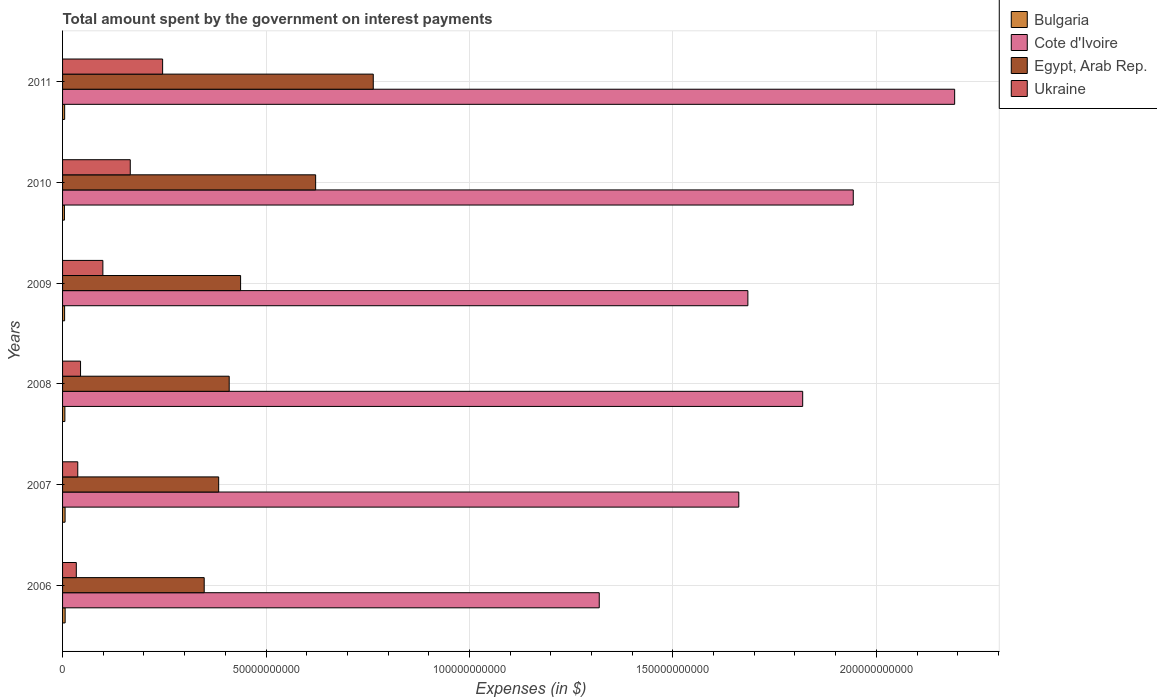How many groups of bars are there?
Provide a succinct answer. 6. Are the number of bars on each tick of the Y-axis equal?
Make the answer very short. Yes. How many bars are there on the 6th tick from the bottom?
Offer a terse response. 4. What is the label of the 6th group of bars from the top?
Your answer should be very brief. 2006. What is the amount spent on interest payments by the government in Cote d'Ivoire in 2010?
Provide a succinct answer. 1.94e+11. Across all years, what is the maximum amount spent on interest payments by the government in Ukraine?
Offer a very short reply. 2.46e+1. Across all years, what is the minimum amount spent on interest payments by the government in Bulgaria?
Provide a short and direct response. 4.60e+08. In which year was the amount spent on interest payments by the government in Bulgaria maximum?
Your answer should be compact. 2006. What is the total amount spent on interest payments by the government in Egypt, Arab Rep. in the graph?
Your answer should be very brief. 2.96e+11. What is the difference between the amount spent on interest payments by the government in Ukraine in 2009 and that in 2011?
Keep it short and to the point. -1.47e+1. What is the difference between the amount spent on interest payments by the government in Egypt, Arab Rep. in 2009 and the amount spent on interest payments by the government in Ukraine in 2008?
Your answer should be compact. 3.93e+1. What is the average amount spent on interest payments by the government in Egypt, Arab Rep. per year?
Your answer should be compact. 4.94e+1. In the year 2010, what is the difference between the amount spent on interest payments by the government in Bulgaria and amount spent on interest payments by the government in Ukraine?
Offer a terse response. -1.62e+1. What is the ratio of the amount spent on interest payments by the government in Bulgaria in 2006 to that in 2008?
Your answer should be very brief. 1.11. Is the difference between the amount spent on interest payments by the government in Bulgaria in 2007 and 2011 greater than the difference between the amount spent on interest payments by the government in Ukraine in 2007 and 2011?
Make the answer very short. Yes. What is the difference between the highest and the second highest amount spent on interest payments by the government in Egypt, Arab Rep.?
Your answer should be compact. 1.42e+1. What is the difference between the highest and the lowest amount spent on interest payments by the government in Cote d'Ivoire?
Your answer should be compact. 8.74e+1. Is it the case that in every year, the sum of the amount spent on interest payments by the government in Bulgaria and amount spent on interest payments by the government in Cote d'Ivoire is greater than the sum of amount spent on interest payments by the government in Egypt, Arab Rep. and amount spent on interest payments by the government in Ukraine?
Make the answer very short. Yes. What is the difference between two consecutive major ticks on the X-axis?
Your answer should be compact. 5.00e+1. Does the graph contain any zero values?
Offer a very short reply. No. Does the graph contain grids?
Your answer should be very brief. Yes. Where does the legend appear in the graph?
Provide a short and direct response. Top right. What is the title of the graph?
Give a very brief answer. Total amount spent by the government on interest payments. What is the label or title of the X-axis?
Your response must be concise. Expenses (in $). What is the Expenses (in $) in Bulgaria in 2006?
Ensure brevity in your answer.  6.32e+08. What is the Expenses (in $) in Cote d'Ivoire in 2006?
Provide a succinct answer. 1.32e+11. What is the Expenses (in $) of Egypt, Arab Rep. in 2006?
Offer a terse response. 3.48e+1. What is the Expenses (in $) of Ukraine in 2006?
Offer a terse response. 3.38e+09. What is the Expenses (in $) of Bulgaria in 2007?
Keep it short and to the point. 6.19e+08. What is the Expenses (in $) of Cote d'Ivoire in 2007?
Your response must be concise. 1.66e+11. What is the Expenses (in $) of Egypt, Arab Rep. in 2007?
Your answer should be very brief. 3.84e+1. What is the Expenses (in $) in Ukraine in 2007?
Your answer should be very brief. 3.74e+09. What is the Expenses (in $) of Bulgaria in 2008?
Keep it short and to the point. 5.69e+08. What is the Expenses (in $) of Cote d'Ivoire in 2008?
Your answer should be very brief. 1.82e+11. What is the Expenses (in $) in Egypt, Arab Rep. in 2008?
Offer a terse response. 4.10e+1. What is the Expenses (in $) of Ukraine in 2008?
Ensure brevity in your answer.  4.42e+09. What is the Expenses (in $) of Bulgaria in 2009?
Your response must be concise. 5.03e+08. What is the Expenses (in $) of Cote d'Ivoire in 2009?
Ensure brevity in your answer.  1.68e+11. What is the Expenses (in $) in Egypt, Arab Rep. in 2009?
Provide a succinct answer. 4.38e+1. What is the Expenses (in $) of Ukraine in 2009?
Keep it short and to the point. 9.91e+09. What is the Expenses (in $) of Bulgaria in 2010?
Ensure brevity in your answer.  4.60e+08. What is the Expenses (in $) in Cote d'Ivoire in 2010?
Keep it short and to the point. 1.94e+11. What is the Expenses (in $) in Egypt, Arab Rep. in 2010?
Keep it short and to the point. 6.22e+1. What is the Expenses (in $) in Ukraine in 2010?
Make the answer very short. 1.66e+1. What is the Expenses (in $) of Bulgaria in 2011?
Ensure brevity in your answer.  5.15e+08. What is the Expenses (in $) of Cote d'Ivoire in 2011?
Your answer should be very brief. 2.19e+11. What is the Expenses (in $) of Egypt, Arab Rep. in 2011?
Your answer should be very brief. 7.64e+1. What is the Expenses (in $) in Ukraine in 2011?
Your answer should be very brief. 2.46e+1. Across all years, what is the maximum Expenses (in $) of Bulgaria?
Offer a terse response. 6.32e+08. Across all years, what is the maximum Expenses (in $) in Cote d'Ivoire?
Offer a terse response. 2.19e+11. Across all years, what is the maximum Expenses (in $) in Egypt, Arab Rep.?
Give a very brief answer. 7.64e+1. Across all years, what is the maximum Expenses (in $) of Ukraine?
Provide a succinct answer. 2.46e+1. Across all years, what is the minimum Expenses (in $) of Bulgaria?
Make the answer very short. 4.60e+08. Across all years, what is the minimum Expenses (in $) in Cote d'Ivoire?
Your response must be concise. 1.32e+11. Across all years, what is the minimum Expenses (in $) of Egypt, Arab Rep.?
Provide a succinct answer. 3.48e+1. Across all years, what is the minimum Expenses (in $) of Ukraine?
Your answer should be very brief. 3.38e+09. What is the total Expenses (in $) in Bulgaria in the graph?
Your answer should be very brief. 3.30e+09. What is the total Expenses (in $) of Cote d'Ivoire in the graph?
Offer a very short reply. 1.06e+12. What is the total Expenses (in $) in Egypt, Arab Rep. in the graph?
Provide a succinct answer. 2.96e+11. What is the total Expenses (in $) in Ukraine in the graph?
Give a very brief answer. 6.27e+1. What is the difference between the Expenses (in $) of Bulgaria in 2006 and that in 2007?
Offer a very short reply. 1.30e+07. What is the difference between the Expenses (in $) of Cote d'Ivoire in 2006 and that in 2007?
Provide a short and direct response. -3.43e+1. What is the difference between the Expenses (in $) of Egypt, Arab Rep. in 2006 and that in 2007?
Make the answer very short. -3.56e+09. What is the difference between the Expenses (in $) in Ukraine in 2006 and that in 2007?
Your answer should be very brief. -3.59e+08. What is the difference between the Expenses (in $) of Bulgaria in 2006 and that in 2008?
Provide a succinct answer. 6.30e+07. What is the difference between the Expenses (in $) in Cote d'Ivoire in 2006 and that in 2008?
Offer a terse response. -5.00e+1. What is the difference between the Expenses (in $) in Egypt, Arab Rep. in 2006 and that in 2008?
Ensure brevity in your answer.  -6.14e+09. What is the difference between the Expenses (in $) of Ukraine in 2006 and that in 2008?
Your response must be concise. -1.04e+09. What is the difference between the Expenses (in $) of Bulgaria in 2006 and that in 2009?
Keep it short and to the point. 1.29e+08. What is the difference between the Expenses (in $) of Cote d'Ivoire in 2006 and that in 2009?
Provide a succinct answer. -3.65e+1. What is the difference between the Expenses (in $) in Egypt, Arab Rep. in 2006 and that in 2009?
Make the answer very short. -8.94e+09. What is the difference between the Expenses (in $) in Ukraine in 2006 and that in 2009?
Give a very brief answer. -6.53e+09. What is the difference between the Expenses (in $) of Bulgaria in 2006 and that in 2010?
Your answer should be compact. 1.72e+08. What is the difference between the Expenses (in $) of Cote d'Ivoire in 2006 and that in 2010?
Offer a very short reply. -6.24e+1. What is the difference between the Expenses (in $) of Egypt, Arab Rep. in 2006 and that in 2010?
Offer a very short reply. -2.74e+1. What is the difference between the Expenses (in $) of Ukraine in 2006 and that in 2010?
Keep it short and to the point. -1.33e+1. What is the difference between the Expenses (in $) of Bulgaria in 2006 and that in 2011?
Make the answer very short. 1.17e+08. What is the difference between the Expenses (in $) in Cote d'Ivoire in 2006 and that in 2011?
Make the answer very short. -8.74e+1. What is the difference between the Expenses (in $) in Egypt, Arab Rep. in 2006 and that in 2011?
Keep it short and to the point. -4.16e+1. What is the difference between the Expenses (in $) in Ukraine in 2006 and that in 2011?
Offer a terse response. -2.12e+1. What is the difference between the Expenses (in $) in Bulgaria in 2007 and that in 2008?
Make the answer very short. 5.00e+07. What is the difference between the Expenses (in $) in Cote d'Ivoire in 2007 and that in 2008?
Offer a very short reply. -1.57e+1. What is the difference between the Expenses (in $) of Egypt, Arab Rep. in 2007 and that in 2008?
Provide a succinct answer. -2.59e+09. What is the difference between the Expenses (in $) of Ukraine in 2007 and that in 2008?
Your response must be concise. -6.83e+08. What is the difference between the Expenses (in $) in Bulgaria in 2007 and that in 2009?
Ensure brevity in your answer.  1.16e+08. What is the difference between the Expenses (in $) in Cote d'Ivoire in 2007 and that in 2009?
Your answer should be compact. -2.23e+09. What is the difference between the Expenses (in $) of Egypt, Arab Rep. in 2007 and that in 2009?
Your answer should be very brief. -5.39e+09. What is the difference between the Expenses (in $) in Ukraine in 2007 and that in 2009?
Your answer should be compact. -6.17e+09. What is the difference between the Expenses (in $) of Bulgaria in 2007 and that in 2010?
Your answer should be compact. 1.59e+08. What is the difference between the Expenses (in $) in Cote d'Ivoire in 2007 and that in 2010?
Provide a short and direct response. -2.81e+1. What is the difference between the Expenses (in $) in Egypt, Arab Rep. in 2007 and that in 2010?
Keep it short and to the point. -2.38e+1. What is the difference between the Expenses (in $) in Ukraine in 2007 and that in 2010?
Offer a very short reply. -1.29e+1. What is the difference between the Expenses (in $) of Bulgaria in 2007 and that in 2011?
Provide a succinct answer. 1.04e+08. What is the difference between the Expenses (in $) in Cote d'Ivoire in 2007 and that in 2011?
Your response must be concise. -5.30e+1. What is the difference between the Expenses (in $) of Egypt, Arab Rep. in 2007 and that in 2011?
Your answer should be compact. -3.80e+1. What is the difference between the Expenses (in $) in Ukraine in 2007 and that in 2011?
Your answer should be very brief. -2.09e+1. What is the difference between the Expenses (in $) of Bulgaria in 2008 and that in 2009?
Make the answer very short. 6.62e+07. What is the difference between the Expenses (in $) of Cote d'Ivoire in 2008 and that in 2009?
Make the answer very short. 1.35e+1. What is the difference between the Expenses (in $) in Egypt, Arab Rep. in 2008 and that in 2009?
Give a very brief answer. -2.80e+09. What is the difference between the Expenses (in $) in Ukraine in 2008 and that in 2009?
Give a very brief answer. -5.49e+09. What is the difference between the Expenses (in $) of Bulgaria in 2008 and that in 2010?
Offer a very short reply. 1.09e+08. What is the difference between the Expenses (in $) of Cote d'Ivoire in 2008 and that in 2010?
Your answer should be very brief. -1.24e+1. What is the difference between the Expenses (in $) of Egypt, Arab Rep. in 2008 and that in 2010?
Keep it short and to the point. -2.12e+1. What is the difference between the Expenses (in $) of Ukraine in 2008 and that in 2010?
Your answer should be very brief. -1.22e+1. What is the difference between the Expenses (in $) of Bulgaria in 2008 and that in 2011?
Give a very brief answer. 5.42e+07. What is the difference between the Expenses (in $) in Cote d'Ivoire in 2008 and that in 2011?
Provide a short and direct response. -3.74e+1. What is the difference between the Expenses (in $) of Egypt, Arab Rep. in 2008 and that in 2011?
Keep it short and to the point. -3.54e+1. What is the difference between the Expenses (in $) of Ukraine in 2008 and that in 2011?
Your response must be concise. -2.02e+1. What is the difference between the Expenses (in $) of Bulgaria in 2009 and that in 2010?
Provide a short and direct response. 4.27e+07. What is the difference between the Expenses (in $) in Cote d'Ivoire in 2009 and that in 2010?
Offer a terse response. -2.59e+1. What is the difference between the Expenses (in $) of Egypt, Arab Rep. in 2009 and that in 2010?
Your answer should be very brief. -1.84e+1. What is the difference between the Expenses (in $) in Ukraine in 2009 and that in 2010?
Ensure brevity in your answer.  -6.73e+09. What is the difference between the Expenses (in $) of Bulgaria in 2009 and that in 2011?
Provide a succinct answer. -1.20e+07. What is the difference between the Expenses (in $) of Cote d'Ivoire in 2009 and that in 2011?
Make the answer very short. -5.08e+1. What is the difference between the Expenses (in $) of Egypt, Arab Rep. in 2009 and that in 2011?
Offer a terse response. -3.26e+1. What is the difference between the Expenses (in $) of Ukraine in 2009 and that in 2011?
Provide a short and direct response. -1.47e+1. What is the difference between the Expenses (in $) of Bulgaria in 2010 and that in 2011?
Provide a succinct answer. -5.47e+07. What is the difference between the Expenses (in $) in Cote d'Ivoire in 2010 and that in 2011?
Your answer should be compact. -2.49e+1. What is the difference between the Expenses (in $) in Egypt, Arab Rep. in 2010 and that in 2011?
Provide a short and direct response. -1.42e+1. What is the difference between the Expenses (in $) in Ukraine in 2010 and that in 2011?
Make the answer very short. -7.95e+09. What is the difference between the Expenses (in $) in Bulgaria in 2006 and the Expenses (in $) in Cote d'Ivoire in 2007?
Provide a short and direct response. -1.66e+11. What is the difference between the Expenses (in $) in Bulgaria in 2006 and the Expenses (in $) in Egypt, Arab Rep. in 2007?
Provide a succinct answer. -3.77e+1. What is the difference between the Expenses (in $) in Bulgaria in 2006 and the Expenses (in $) in Ukraine in 2007?
Your answer should be compact. -3.10e+09. What is the difference between the Expenses (in $) of Cote d'Ivoire in 2006 and the Expenses (in $) of Egypt, Arab Rep. in 2007?
Provide a short and direct response. 9.35e+1. What is the difference between the Expenses (in $) in Cote d'Ivoire in 2006 and the Expenses (in $) in Ukraine in 2007?
Your answer should be compact. 1.28e+11. What is the difference between the Expenses (in $) of Egypt, Arab Rep. in 2006 and the Expenses (in $) of Ukraine in 2007?
Make the answer very short. 3.11e+1. What is the difference between the Expenses (in $) in Bulgaria in 2006 and the Expenses (in $) in Cote d'Ivoire in 2008?
Your answer should be very brief. -1.81e+11. What is the difference between the Expenses (in $) in Bulgaria in 2006 and the Expenses (in $) in Egypt, Arab Rep. in 2008?
Provide a succinct answer. -4.03e+1. What is the difference between the Expenses (in $) in Bulgaria in 2006 and the Expenses (in $) in Ukraine in 2008?
Give a very brief answer. -3.79e+09. What is the difference between the Expenses (in $) of Cote d'Ivoire in 2006 and the Expenses (in $) of Egypt, Arab Rep. in 2008?
Give a very brief answer. 9.09e+1. What is the difference between the Expenses (in $) of Cote d'Ivoire in 2006 and the Expenses (in $) of Ukraine in 2008?
Provide a succinct answer. 1.27e+11. What is the difference between the Expenses (in $) of Egypt, Arab Rep. in 2006 and the Expenses (in $) of Ukraine in 2008?
Ensure brevity in your answer.  3.04e+1. What is the difference between the Expenses (in $) in Bulgaria in 2006 and the Expenses (in $) in Cote d'Ivoire in 2009?
Ensure brevity in your answer.  -1.68e+11. What is the difference between the Expenses (in $) of Bulgaria in 2006 and the Expenses (in $) of Egypt, Arab Rep. in 2009?
Your answer should be very brief. -4.31e+1. What is the difference between the Expenses (in $) in Bulgaria in 2006 and the Expenses (in $) in Ukraine in 2009?
Make the answer very short. -9.28e+09. What is the difference between the Expenses (in $) in Cote d'Ivoire in 2006 and the Expenses (in $) in Egypt, Arab Rep. in 2009?
Your answer should be very brief. 8.81e+1. What is the difference between the Expenses (in $) in Cote d'Ivoire in 2006 and the Expenses (in $) in Ukraine in 2009?
Offer a very short reply. 1.22e+11. What is the difference between the Expenses (in $) in Egypt, Arab Rep. in 2006 and the Expenses (in $) in Ukraine in 2009?
Give a very brief answer. 2.49e+1. What is the difference between the Expenses (in $) in Bulgaria in 2006 and the Expenses (in $) in Cote d'Ivoire in 2010?
Offer a very short reply. -1.94e+11. What is the difference between the Expenses (in $) of Bulgaria in 2006 and the Expenses (in $) of Egypt, Arab Rep. in 2010?
Your response must be concise. -6.16e+1. What is the difference between the Expenses (in $) of Bulgaria in 2006 and the Expenses (in $) of Ukraine in 2010?
Offer a terse response. -1.60e+1. What is the difference between the Expenses (in $) of Cote d'Ivoire in 2006 and the Expenses (in $) of Egypt, Arab Rep. in 2010?
Your answer should be very brief. 6.97e+1. What is the difference between the Expenses (in $) in Cote d'Ivoire in 2006 and the Expenses (in $) in Ukraine in 2010?
Provide a short and direct response. 1.15e+11. What is the difference between the Expenses (in $) of Egypt, Arab Rep. in 2006 and the Expenses (in $) of Ukraine in 2010?
Provide a succinct answer. 1.82e+1. What is the difference between the Expenses (in $) in Bulgaria in 2006 and the Expenses (in $) in Cote d'Ivoire in 2011?
Offer a terse response. -2.19e+11. What is the difference between the Expenses (in $) in Bulgaria in 2006 and the Expenses (in $) in Egypt, Arab Rep. in 2011?
Offer a terse response. -7.57e+1. What is the difference between the Expenses (in $) in Bulgaria in 2006 and the Expenses (in $) in Ukraine in 2011?
Ensure brevity in your answer.  -2.40e+1. What is the difference between the Expenses (in $) in Cote d'Ivoire in 2006 and the Expenses (in $) in Egypt, Arab Rep. in 2011?
Your answer should be very brief. 5.55e+1. What is the difference between the Expenses (in $) in Cote d'Ivoire in 2006 and the Expenses (in $) in Ukraine in 2011?
Provide a short and direct response. 1.07e+11. What is the difference between the Expenses (in $) in Egypt, Arab Rep. in 2006 and the Expenses (in $) in Ukraine in 2011?
Your response must be concise. 1.02e+1. What is the difference between the Expenses (in $) in Bulgaria in 2007 and the Expenses (in $) in Cote d'Ivoire in 2008?
Keep it short and to the point. -1.81e+11. What is the difference between the Expenses (in $) in Bulgaria in 2007 and the Expenses (in $) in Egypt, Arab Rep. in 2008?
Your response must be concise. -4.03e+1. What is the difference between the Expenses (in $) in Bulgaria in 2007 and the Expenses (in $) in Ukraine in 2008?
Keep it short and to the point. -3.80e+09. What is the difference between the Expenses (in $) of Cote d'Ivoire in 2007 and the Expenses (in $) of Egypt, Arab Rep. in 2008?
Offer a terse response. 1.25e+11. What is the difference between the Expenses (in $) in Cote d'Ivoire in 2007 and the Expenses (in $) in Ukraine in 2008?
Provide a succinct answer. 1.62e+11. What is the difference between the Expenses (in $) of Egypt, Arab Rep. in 2007 and the Expenses (in $) of Ukraine in 2008?
Provide a short and direct response. 3.39e+1. What is the difference between the Expenses (in $) in Bulgaria in 2007 and the Expenses (in $) in Cote d'Ivoire in 2009?
Keep it short and to the point. -1.68e+11. What is the difference between the Expenses (in $) of Bulgaria in 2007 and the Expenses (in $) of Egypt, Arab Rep. in 2009?
Provide a short and direct response. -4.31e+1. What is the difference between the Expenses (in $) in Bulgaria in 2007 and the Expenses (in $) in Ukraine in 2009?
Offer a very short reply. -9.29e+09. What is the difference between the Expenses (in $) of Cote d'Ivoire in 2007 and the Expenses (in $) of Egypt, Arab Rep. in 2009?
Your answer should be compact. 1.22e+11. What is the difference between the Expenses (in $) of Cote d'Ivoire in 2007 and the Expenses (in $) of Ukraine in 2009?
Your answer should be very brief. 1.56e+11. What is the difference between the Expenses (in $) in Egypt, Arab Rep. in 2007 and the Expenses (in $) in Ukraine in 2009?
Your answer should be very brief. 2.85e+1. What is the difference between the Expenses (in $) in Bulgaria in 2007 and the Expenses (in $) in Cote d'Ivoire in 2010?
Your answer should be compact. -1.94e+11. What is the difference between the Expenses (in $) of Bulgaria in 2007 and the Expenses (in $) of Egypt, Arab Rep. in 2010?
Keep it short and to the point. -6.16e+1. What is the difference between the Expenses (in $) in Bulgaria in 2007 and the Expenses (in $) in Ukraine in 2010?
Provide a succinct answer. -1.60e+1. What is the difference between the Expenses (in $) in Cote d'Ivoire in 2007 and the Expenses (in $) in Egypt, Arab Rep. in 2010?
Your response must be concise. 1.04e+11. What is the difference between the Expenses (in $) of Cote d'Ivoire in 2007 and the Expenses (in $) of Ukraine in 2010?
Give a very brief answer. 1.50e+11. What is the difference between the Expenses (in $) of Egypt, Arab Rep. in 2007 and the Expenses (in $) of Ukraine in 2010?
Provide a succinct answer. 2.17e+1. What is the difference between the Expenses (in $) of Bulgaria in 2007 and the Expenses (in $) of Cote d'Ivoire in 2011?
Provide a succinct answer. -2.19e+11. What is the difference between the Expenses (in $) of Bulgaria in 2007 and the Expenses (in $) of Egypt, Arab Rep. in 2011?
Give a very brief answer. -7.57e+1. What is the difference between the Expenses (in $) in Bulgaria in 2007 and the Expenses (in $) in Ukraine in 2011?
Give a very brief answer. -2.40e+1. What is the difference between the Expenses (in $) of Cote d'Ivoire in 2007 and the Expenses (in $) of Egypt, Arab Rep. in 2011?
Make the answer very short. 8.98e+1. What is the difference between the Expenses (in $) in Cote d'Ivoire in 2007 and the Expenses (in $) in Ukraine in 2011?
Offer a terse response. 1.42e+11. What is the difference between the Expenses (in $) of Egypt, Arab Rep. in 2007 and the Expenses (in $) of Ukraine in 2011?
Offer a terse response. 1.38e+1. What is the difference between the Expenses (in $) in Bulgaria in 2008 and the Expenses (in $) in Cote d'Ivoire in 2009?
Your response must be concise. -1.68e+11. What is the difference between the Expenses (in $) of Bulgaria in 2008 and the Expenses (in $) of Egypt, Arab Rep. in 2009?
Give a very brief answer. -4.32e+1. What is the difference between the Expenses (in $) in Bulgaria in 2008 and the Expenses (in $) in Ukraine in 2009?
Your response must be concise. -9.34e+09. What is the difference between the Expenses (in $) of Cote d'Ivoire in 2008 and the Expenses (in $) of Egypt, Arab Rep. in 2009?
Provide a succinct answer. 1.38e+11. What is the difference between the Expenses (in $) in Cote d'Ivoire in 2008 and the Expenses (in $) in Ukraine in 2009?
Give a very brief answer. 1.72e+11. What is the difference between the Expenses (in $) of Egypt, Arab Rep. in 2008 and the Expenses (in $) of Ukraine in 2009?
Your response must be concise. 3.10e+1. What is the difference between the Expenses (in $) of Bulgaria in 2008 and the Expenses (in $) of Cote d'Ivoire in 2010?
Ensure brevity in your answer.  -1.94e+11. What is the difference between the Expenses (in $) in Bulgaria in 2008 and the Expenses (in $) in Egypt, Arab Rep. in 2010?
Offer a terse response. -6.16e+1. What is the difference between the Expenses (in $) of Bulgaria in 2008 and the Expenses (in $) of Ukraine in 2010?
Your answer should be compact. -1.61e+1. What is the difference between the Expenses (in $) of Cote d'Ivoire in 2008 and the Expenses (in $) of Egypt, Arab Rep. in 2010?
Offer a terse response. 1.20e+11. What is the difference between the Expenses (in $) of Cote d'Ivoire in 2008 and the Expenses (in $) of Ukraine in 2010?
Your response must be concise. 1.65e+11. What is the difference between the Expenses (in $) of Egypt, Arab Rep. in 2008 and the Expenses (in $) of Ukraine in 2010?
Offer a terse response. 2.43e+1. What is the difference between the Expenses (in $) of Bulgaria in 2008 and the Expenses (in $) of Cote d'Ivoire in 2011?
Your answer should be compact. -2.19e+11. What is the difference between the Expenses (in $) in Bulgaria in 2008 and the Expenses (in $) in Egypt, Arab Rep. in 2011?
Your answer should be very brief. -7.58e+1. What is the difference between the Expenses (in $) in Bulgaria in 2008 and the Expenses (in $) in Ukraine in 2011?
Give a very brief answer. -2.40e+1. What is the difference between the Expenses (in $) of Cote d'Ivoire in 2008 and the Expenses (in $) of Egypt, Arab Rep. in 2011?
Offer a terse response. 1.06e+11. What is the difference between the Expenses (in $) in Cote d'Ivoire in 2008 and the Expenses (in $) in Ukraine in 2011?
Ensure brevity in your answer.  1.57e+11. What is the difference between the Expenses (in $) of Egypt, Arab Rep. in 2008 and the Expenses (in $) of Ukraine in 2011?
Provide a short and direct response. 1.64e+1. What is the difference between the Expenses (in $) in Bulgaria in 2009 and the Expenses (in $) in Cote d'Ivoire in 2010?
Offer a terse response. -1.94e+11. What is the difference between the Expenses (in $) of Bulgaria in 2009 and the Expenses (in $) of Egypt, Arab Rep. in 2010?
Your response must be concise. -6.17e+1. What is the difference between the Expenses (in $) in Bulgaria in 2009 and the Expenses (in $) in Ukraine in 2010?
Provide a succinct answer. -1.61e+1. What is the difference between the Expenses (in $) in Cote d'Ivoire in 2009 and the Expenses (in $) in Egypt, Arab Rep. in 2010?
Ensure brevity in your answer.  1.06e+11. What is the difference between the Expenses (in $) in Cote d'Ivoire in 2009 and the Expenses (in $) in Ukraine in 2010?
Offer a terse response. 1.52e+11. What is the difference between the Expenses (in $) in Egypt, Arab Rep. in 2009 and the Expenses (in $) in Ukraine in 2010?
Offer a very short reply. 2.71e+1. What is the difference between the Expenses (in $) of Bulgaria in 2009 and the Expenses (in $) of Cote d'Ivoire in 2011?
Give a very brief answer. -2.19e+11. What is the difference between the Expenses (in $) in Bulgaria in 2009 and the Expenses (in $) in Egypt, Arab Rep. in 2011?
Offer a very short reply. -7.59e+1. What is the difference between the Expenses (in $) in Bulgaria in 2009 and the Expenses (in $) in Ukraine in 2011?
Offer a terse response. -2.41e+1. What is the difference between the Expenses (in $) in Cote d'Ivoire in 2009 and the Expenses (in $) in Egypt, Arab Rep. in 2011?
Your answer should be very brief. 9.21e+1. What is the difference between the Expenses (in $) of Cote d'Ivoire in 2009 and the Expenses (in $) of Ukraine in 2011?
Your answer should be very brief. 1.44e+11. What is the difference between the Expenses (in $) of Egypt, Arab Rep. in 2009 and the Expenses (in $) of Ukraine in 2011?
Your answer should be very brief. 1.92e+1. What is the difference between the Expenses (in $) of Bulgaria in 2010 and the Expenses (in $) of Cote d'Ivoire in 2011?
Provide a short and direct response. -2.19e+11. What is the difference between the Expenses (in $) in Bulgaria in 2010 and the Expenses (in $) in Egypt, Arab Rep. in 2011?
Keep it short and to the point. -7.59e+1. What is the difference between the Expenses (in $) in Bulgaria in 2010 and the Expenses (in $) in Ukraine in 2011?
Your answer should be very brief. -2.41e+1. What is the difference between the Expenses (in $) in Cote d'Ivoire in 2010 and the Expenses (in $) in Egypt, Arab Rep. in 2011?
Keep it short and to the point. 1.18e+11. What is the difference between the Expenses (in $) of Cote d'Ivoire in 2010 and the Expenses (in $) of Ukraine in 2011?
Your answer should be compact. 1.70e+11. What is the difference between the Expenses (in $) of Egypt, Arab Rep. in 2010 and the Expenses (in $) of Ukraine in 2011?
Give a very brief answer. 3.76e+1. What is the average Expenses (in $) in Bulgaria per year?
Offer a terse response. 5.49e+08. What is the average Expenses (in $) of Cote d'Ivoire per year?
Make the answer very short. 1.77e+11. What is the average Expenses (in $) in Egypt, Arab Rep. per year?
Offer a very short reply. 4.94e+1. What is the average Expenses (in $) of Ukraine per year?
Your answer should be compact. 1.04e+1. In the year 2006, what is the difference between the Expenses (in $) in Bulgaria and Expenses (in $) in Cote d'Ivoire?
Your response must be concise. -1.31e+11. In the year 2006, what is the difference between the Expenses (in $) of Bulgaria and Expenses (in $) of Egypt, Arab Rep.?
Your answer should be compact. -3.42e+1. In the year 2006, what is the difference between the Expenses (in $) in Bulgaria and Expenses (in $) in Ukraine?
Your answer should be compact. -2.75e+09. In the year 2006, what is the difference between the Expenses (in $) in Cote d'Ivoire and Expenses (in $) in Egypt, Arab Rep.?
Keep it short and to the point. 9.71e+1. In the year 2006, what is the difference between the Expenses (in $) of Cote d'Ivoire and Expenses (in $) of Ukraine?
Give a very brief answer. 1.29e+11. In the year 2006, what is the difference between the Expenses (in $) in Egypt, Arab Rep. and Expenses (in $) in Ukraine?
Make the answer very short. 3.14e+1. In the year 2007, what is the difference between the Expenses (in $) of Bulgaria and Expenses (in $) of Cote d'Ivoire?
Keep it short and to the point. -1.66e+11. In the year 2007, what is the difference between the Expenses (in $) in Bulgaria and Expenses (in $) in Egypt, Arab Rep.?
Offer a very short reply. -3.77e+1. In the year 2007, what is the difference between the Expenses (in $) of Bulgaria and Expenses (in $) of Ukraine?
Make the answer very short. -3.12e+09. In the year 2007, what is the difference between the Expenses (in $) of Cote d'Ivoire and Expenses (in $) of Egypt, Arab Rep.?
Keep it short and to the point. 1.28e+11. In the year 2007, what is the difference between the Expenses (in $) in Cote d'Ivoire and Expenses (in $) in Ukraine?
Your answer should be very brief. 1.62e+11. In the year 2007, what is the difference between the Expenses (in $) in Egypt, Arab Rep. and Expenses (in $) in Ukraine?
Offer a very short reply. 3.46e+1. In the year 2008, what is the difference between the Expenses (in $) of Bulgaria and Expenses (in $) of Cote d'Ivoire?
Your answer should be compact. -1.81e+11. In the year 2008, what is the difference between the Expenses (in $) of Bulgaria and Expenses (in $) of Egypt, Arab Rep.?
Keep it short and to the point. -4.04e+1. In the year 2008, what is the difference between the Expenses (in $) of Bulgaria and Expenses (in $) of Ukraine?
Your response must be concise. -3.85e+09. In the year 2008, what is the difference between the Expenses (in $) in Cote d'Ivoire and Expenses (in $) in Egypt, Arab Rep.?
Your answer should be very brief. 1.41e+11. In the year 2008, what is the difference between the Expenses (in $) of Cote d'Ivoire and Expenses (in $) of Ukraine?
Provide a short and direct response. 1.77e+11. In the year 2008, what is the difference between the Expenses (in $) in Egypt, Arab Rep. and Expenses (in $) in Ukraine?
Your answer should be compact. 3.65e+1. In the year 2009, what is the difference between the Expenses (in $) of Bulgaria and Expenses (in $) of Cote d'Ivoire?
Ensure brevity in your answer.  -1.68e+11. In the year 2009, what is the difference between the Expenses (in $) in Bulgaria and Expenses (in $) in Egypt, Arab Rep.?
Provide a succinct answer. -4.33e+1. In the year 2009, what is the difference between the Expenses (in $) of Bulgaria and Expenses (in $) of Ukraine?
Your response must be concise. -9.40e+09. In the year 2009, what is the difference between the Expenses (in $) of Cote d'Ivoire and Expenses (in $) of Egypt, Arab Rep.?
Provide a short and direct response. 1.25e+11. In the year 2009, what is the difference between the Expenses (in $) in Cote d'Ivoire and Expenses (in $) in Ukraine?
Your answer should be compact. 1.59e+11. In the year 2009, what is the difference between the Expenses (in $) of Egypt, Arab Rep. and Expenses (in $) of Ukraine?
Keep it short and to the point. 3.38e+1. In the year 2010, what is the difference between the Expenses (in $) in Bulgaria and Expenses (in $) in Cote d'Ivoire?
Offer a terse response. -1.94e+11. In the year 2010, what is the difference between the Expenses (in $) of Bulgaria and Expenses (in $) of Egypt, Arab Rep.?
Your answer should be very brief. -6.17e+1. In the year 2010, what is the difference between the Expenses (in $) in Bulgaria and Expenses (in $) in Ukraine?
Make the answer very short. -1.62e+1. In the year 2010, what is the difference between the Expenses (in $) in Cote d'Ivoire and Expenses (in $) in Egypt, Arab Rep.?
Offer a terse response. 1.32e+11. In the year 2010, what is the difference between the Expenses (in $) in Cote d'Ivoire and Expenses (in $) in Ukraine?
Offer a very short reply. 1.78e+11. In the year 2010, what is the difference between the Expenses (in $) in Egypt, Arab Rep. and Expenses (in $) in Ukraine?
Give a very brief answer. 4.56e+1. In the year 2011, what is the difference between the Expenses (in $) of Bulgaria and Expenses (in $) of Cote d'Ivoire?
Ensure brevity in your answer.  -2.19e+11. In the year 2011, what is the difference between the Expenses (in $) of Bulgaria and Expenses (in $) of Egypt, Arab Rep.?
Ensure brevity in your answer.  -7.58e+1. In the year 2011, what is the difference between the Expenses (in $) of Bulgaria and Expenses (in $) of Ukraine?
Make the answer very short. -2.41e+1. In the year 2011, what is the difference between the Expenses (in $) of Cote d'Ivoire and Expenses (in $) of Egypt, Arab Rep.?
Your answer should be very brief. 1.43e+11. In the year 2011, what is the difference between the Expenses (in $) in Cote d'Ivoire and Expenses (in $) in Ukraine?
Your answer should be compact. 1.95e+11. In the year 2011, what is the difference between the Expenses (in $) of Egypt, Arab Rep. and Expenses (in $) of Ukraine?
Your answer should be compact. 5.18e+1. What is the ratio of the Expenses (in $) in Cote d'Ivoire in 2006 to that in 2007?
Offer a very short reply. 0.79. What is the ratio of the Expenses (in $) of Egypt, Arab Rep. in 2006 to that in 2007?
Make the answer very short. 0.91. What is the ratio of the Expenses (in $) in Ukraine in 2006 to that in 2007?
Keep it short and to the point. 0.9. What is the ratio of the Expenses (in $) in Bulgaria in 2006 to that in 2008?
Your response must be concise. 1.11. What is the ratio of the Expenses (in $) of Cote d'Ivoire in 2006 to that in 2008?
Offer a terse response. 0.73. What is the ratio of the Expenses (in $) of Ukraine in 2006 to that in 2008?
Your answer should be very brief. 0.76. What is the ratio of the Expenses (in $) of Bulgaria in 2006 to that in 2009?
Make the answer very short. 1.26. What is the ratio of the Expenses (in $) of Cote d'Ivoire in 2006 to that in 2009?
Ensure brevity in your answer.  0.78. What is the ratio of the Expenses (in $) of Egypt, Arab Rep. in 2006 to that in 2009?
Your answer should be very brief. 0.8. What is the ratio of the Expenses (in $) of Ukraine in 2006 to that in 2009?
Ensure brevity in your answer.  0.34. What is the ratio of the Expenses (in $) in Bulgaria in 2006 to that in 2010?
Give a very brief answer. 1.37. What is the ratio of the Expenses (in $) in Cote d'Ivoire in 2006 to that in 2010?
Your answer should be compact. 0.68. What is the ratio of the Expenses (in $) in Egypt, Arab Rep. in 2006 to that in 2010?
Provide a short and direct response. 0.56. What is the ratio of the Expenses (in $) of Ukraine in 2006 to that in 2010?
Offer a very short reply. 0.2. What is the ratio of the Expenses (in $) in Bulgaria in 2006 to that in 2011?
Offer a terse response. 1.23. What is the ratio of the Expenses (in $) of Cote d'Ivoire in 2006 to that in 2011?
Provide a succinct answer. 0.6. What is the ratio of the Expenses (in $) of Egypt, Arab Rep. in 2006 to that in 2011?
Your answer should be compact. 0.46. What is the ratio of the Expenses (in $) of Ukraine in 2006 to that in 2011?
Your response must be concise. 0.14. What is the ratio of the Expenses (in $) in Bulgaria in 2007 to that in 2008?
Make the answer very short. 1.09. What is the ratio of the Expenses (in $) in Cote d'Ivoire in 2007 to that in 2008?
Offer a very short reply. 0.91. What is the ratio of the Expenses (in $) in Egypt, Arab Rep. in 2007 to that in 2008?
Your answer should be very brief. 0.94. What is the ratio of the Expenses (in $) in Ukraine in 2007 to that in 2008?
Provide a short and direct response. 0.85. What is the ratio of the Expenses (in $) in Bulgaria in 2007 to that in 2009?
Offer a very short reply. 1.23. What is the ratio of the Expenses (in $) of Egypt, Arab Rep. in 2007 to that in 2009?
Your response must be concise. 0.88. What is the ratio of the Expenses (in $) in Ukraine in 2007 to that in 2009?
Your answer should be very brief. 0.38. What is the ratio of the Expenses (in $) of Bulgaria in 2007 to that in 2010?
Your answer should be very brief. 1.35. What is the ratio of the Expenses (in $) of Cote d'Ivoire in 2007 to that in 2010?
Your answer should be very brief. 0.86. What is the ratio of the Expenses (in $) in Egypt, Arab Rep. in 2007 to that in 2010?
Keep it short and to the point. 0.62. What is the ratio of the Expenses (in $) in Ukraine in 2007 to that in 2010?
Your answer should be very brief. 0.22. What is the ratio of the Expenses (in $) in Bulgaria in 2007 to that in 2011?
Give a very brief answer. 1.2. What is the ratio of the Expenses (in $) of Cote d'Ivoire in 2007 to that in 2011?
Your response must be concise. 0.76. What is the ratio of the Expenses (in $) in Egypt, Arab Rep. in 2007 to that in 2011?
Provide a succinct answer. 0.5. What is the ratio of the Expenses (in $) in Ukraine in 2007 to that in 2011?
Your answer should be very brief. 0.15. What is the ratio of the Expenses (in $) of Bulgaria in 2008 to that in 2009?
Provide a short and direct response. 1.13. What is the ratio of the Expenses (in $) in Cote d'Ivoire in 2008 to that in 2009?
Offer a very short reply. 1.08. What is the ratio of the Expenses (in $) in Egypt, Arab Rep. in 2008 to that in 2009?
Ensure brevity in your answer.  0.94. What is the ratio of the Expenses (in $) of Ukraine in 2008 to that in 2009?
Your answer should be very brief. 0.45. What is the ratio of the Expenses (in $) in Bulgaria in 2008 to that in 2010?
Provide a short and direct response. 1.24. What is the ratio of the Expenses (in $) of Cote d'Ivoire in 2008 to that in 2010?
Offer a very short reply. 0.94. What is the ratio of the Expenses (in $) in Egypt, Arab Rep. in 2008 to that in 2010?
Ensure brevity in your answer.  0.66. What is the ratio of the Expenses (in $) in Ukraine in 2008 to that in 2010?
Your response must be concise. 0.27. What is the ratio of the Expenses (in $) in Bulgaria in 2008 to that in 2011?
Keep it short and to the point. 1.11. What is the ratio of the Expenses (in $) in Cote d'Ivoire in 2008 to that in 2011?
Give a very brief answer. 0.83. What is the ratio of the Expenses (in $) in Egypt, Arab Rep. in 2008 to that in 2011?
Provide a succinct answer. 0.54. What is the ratio of the Expenses (in $) of Ukraine in 2008 to that in 2011?
Offer a very short reply. 0.18. What is the ratio of the Expenses (in $) of Bulgaria in 2009 to that in 2010?
Provide a short and direct response. 1.09. What is the ratio of the Expenses (in $) in Cote d'Ivoire in 2009 to that in 2010?
Your answer should be very brief. 0.87. What is the ratio of the Expenses (in $) of Egypt, Arab Rep. in 2009 to that in 2010?
Provide a succinct answer. 0.7. What is the ratio of the Expenses (in $) in Ukraine in 2009 to that in 2010?
Provide a succinct answer. 0.6. What is the ratio of the Expenses (in $) of Bulgaria in 2009 to that in 2011?
Offer a very short reply. 0.98. What is the ratio of the Expenses (in $) in Cote d'Ivoire in 2009 to that in 2011?
Provide a succinct answer. 0.77. What is the ratio of the Expenses (in $) of Egypt, Arab Rep. in 2009 to that in 2011?
Provide a succinct answer. 0.57. What is the ratio of the Expenses (in $) of Ukraine in 2009 to that in 2011?
Offer a terse response. 0.4. What is the ratio of the Expenses (in $) in Bulgaria in 2010 to that in 2011?
Give a very brief answer. 0.89. What is the ratio of the Expenses (in $) of Cote d'Ivoire in 2010 to that in 2011?
Give a very brief answer. 0.89. What is the ratio of the Expenses (in $) of Egypt, Arab Rep. in 2010 to that in 2011?
Offer a terse response. 0.81. What is the ratio of the Expenses (in $) of Ukraine in 2010 to that in 2011?
Give a very brief answer. 0.68. What is the difference between the highest and the second highest Expenses (in $) in Bulgaria?
Keep it short and to the point. 1.30e+07. What is the difference between the highest and the second highest Expenses (in $) in Cote d'Ivoire?
Make the answer very short. 2.49e+1. What is the difference between the highest and the second highest Expenses (in $) of Egypt, Arab Rep.?
Make the answer very short. 1.42e+1. What is the difference between the highest and the second highest Expenses (in $) in Ukraine?
Ensure brevity in your answer.  7.95e+09. What is the difference between the highest and the lowest Expenses (in $) in Bulgaria?
Provide a short and direct response. 1.72e+08. What is the difference between the highest and the lowest Expenses (in $) in Cote d'Ivoire?
Make the answer very short. 8.74e+1. What is the difference between the highest and the lowest Expenses (in $) of Egypt, Arab Rep.?
Offer a very short reply. 4.16e+1. What is the difference between the highest and the lowest Expenses (in $) in Ukraine?
Make the answer very short. 2.12e+1. 